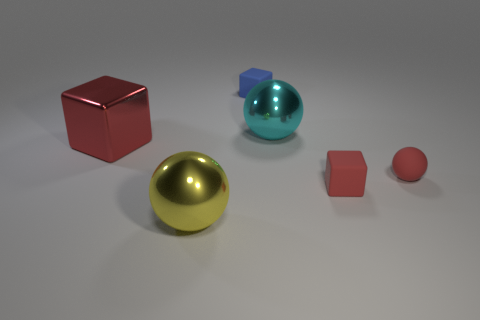Subtract all purple cubes. Subtract all yellow spheres. How many cubes are left? 3 Add 3 big cyan blocks. How many objects exist? 9 Add 6 cyan rubber blocks. How many cyan rubber blocks exist? 6 Subtract 2 red blocks. How many objects are left? 4 Subtract all large cyan spheres. Subtract all small gray matte cubes. How many objects are left? 5 Add 4 cyan shiny spheres. How many cyan shiny spheres are left? 5 